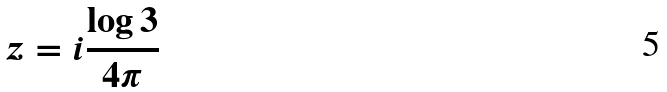<formula> <loc_0><loc_0><loc_500><loc_500>z = i \frac { \log 3 } { 4 \pi }</formula> 